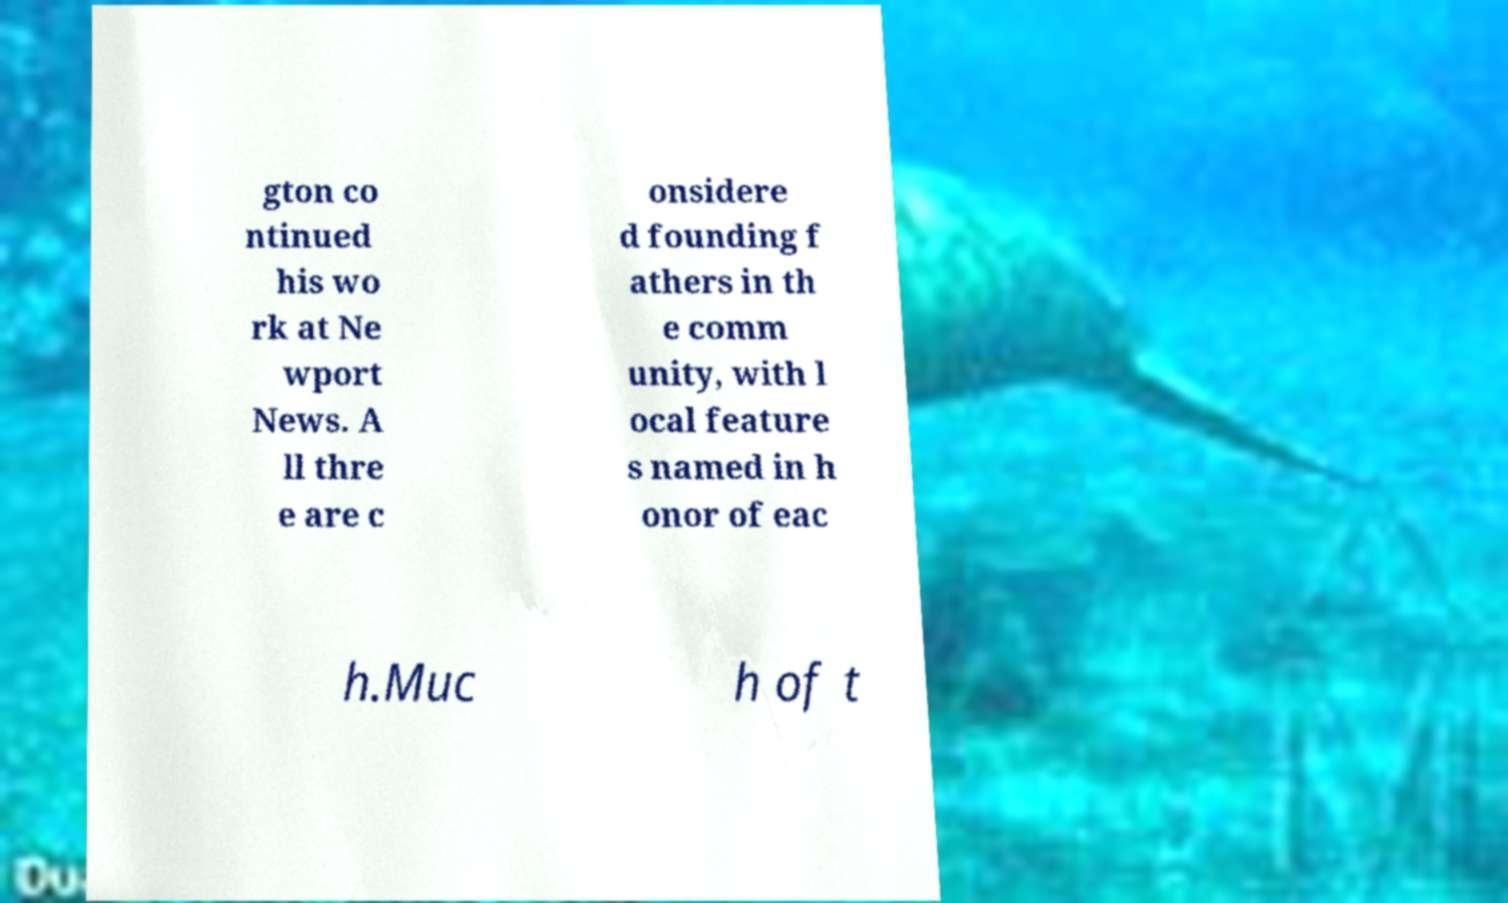Please read and relay the text visible in this image. What does it say? gton co ntinued his wo rk at Ne wport News. A ll thre e are c onsidere d founding f athers in th e comm unity, with l ocal feature s named in h onor of eac h.Muc h of t 